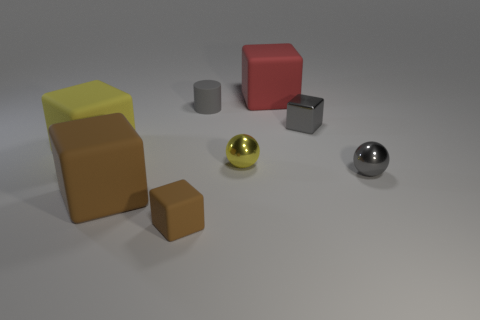Do the big matte thing that is in front of the yellow matte block and the small rubber cube have the same color?
Keep it short and to the point. Yes. What shape is the matte thing that is the same color as the shiny block?
Your response must be concise. Cylinder. Are there any small gray blocks made of the same material as the yellow block?
Your response must be concise. No. The large brown thing is what shape?
Give a very brief answer. Cube. How many big gray matte blocks are there?
Offer a very short reply. 0. The cylinder behind the small rubber object in front of the yellow shiny sphere is what color?
Provide a short and direct response. Gray. What is the color of the matte thing that is the same size as the gray cylinder?
Offer a very short reply. Brown. Is there a object that has the same color as the tiny metallic block?
Offer a terse response. Yes. Are any green matte blocks visible?
Keep it short and to the point. No. There is a brown object on the left side of the small brown matte object; what is its shape?
Your response must be concise. Cube. 